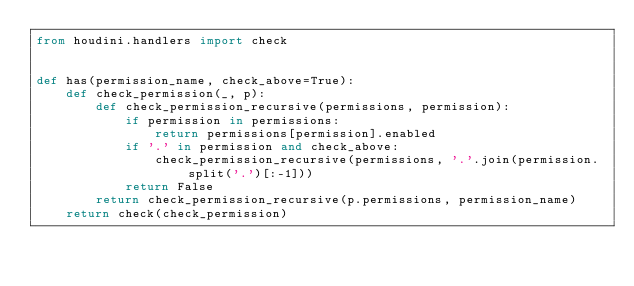<code> <loc_0><loc_0><loc_500><loc_500><_Python_>from houdini.handlers import check


def has(permission_name, check_above=True):
    def check_permission(_, p):
        def check_permission_recursive(permissions, permission):
            if permission in permissions:
                return permissions[permission].enabled
            if '.' in permission and check_above:
                check_permission_recursive(permissions, '.'.join(permission.split('.')[:-1]))
            return False
        return check_permission_recursive(p.permissions, permission_name)
    return check(check_permission)
</code> 